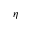Convert formula to latex. <formula><loc_0><loc_0><loc_500><loc_500>\eta</formula> 